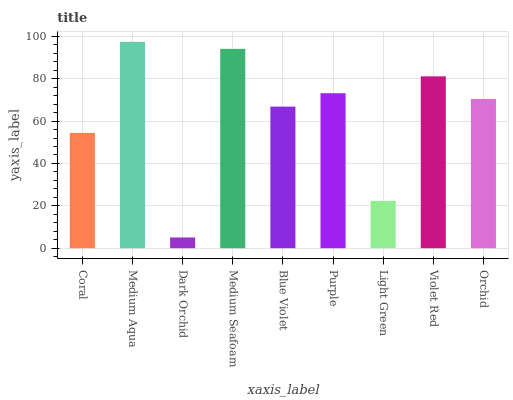Is Medium Aqua the minimum?
Answer yes or no. No. Is Dark Orchid the maximum?
Answer yes or no. No. Is Medium Aqua greater than Dark Orchid?
Answer yes or no. Yes. Is Dark Orchid less than Medium Aqua?
Answer yes or no. Yes. Is Dark Orchid greater than Medium Aqua?
Answer yes or no. No. Is Medium Aqua less than Dark Orchid?
Answer yes or no. No. Is Orchid the high median?
Answer yes or no. Yes. Is Orchid the low median?
Answer yes or no. Yes. Is Light Green the high median?
Answer yes or no. No. Is Dark Orchid the low median?
Answer yes or no. No. 